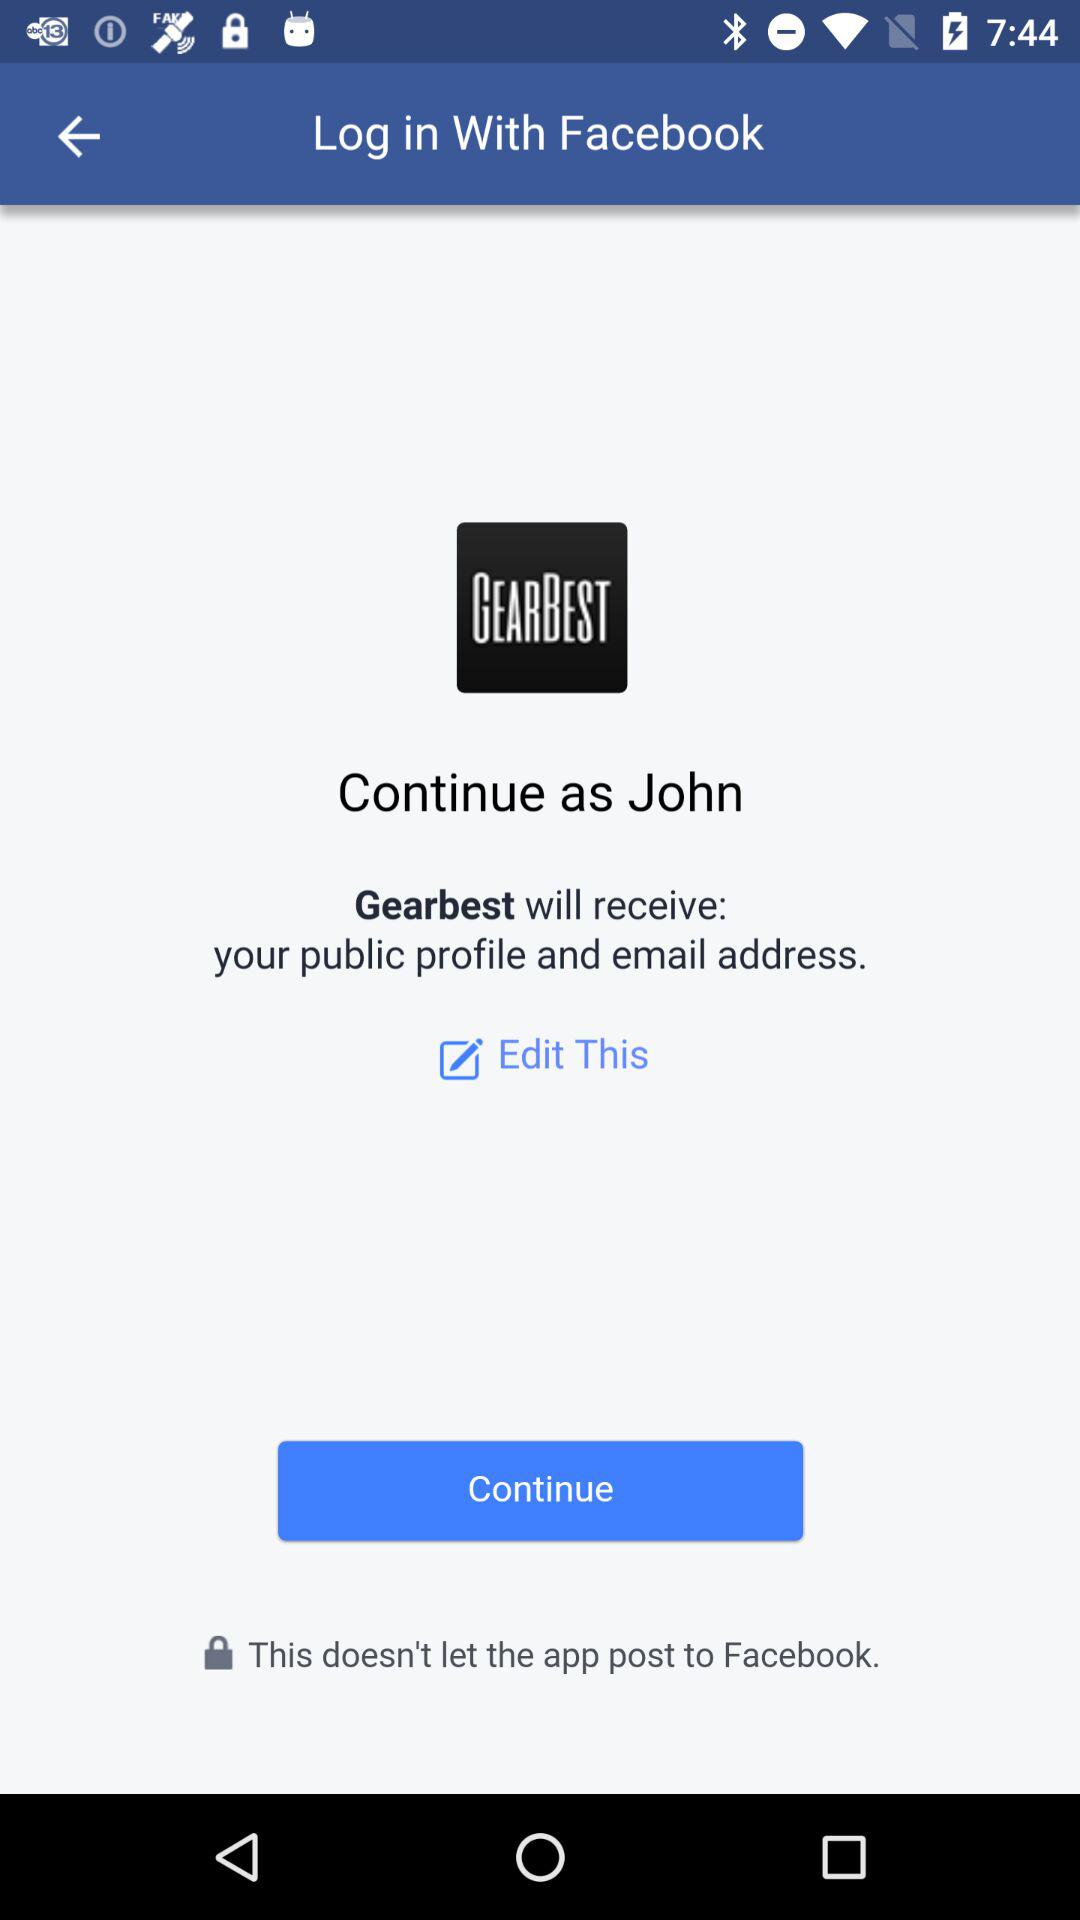What is John's surname?
When the provided information is insufficient, respond with <no answer>. <no answer> 